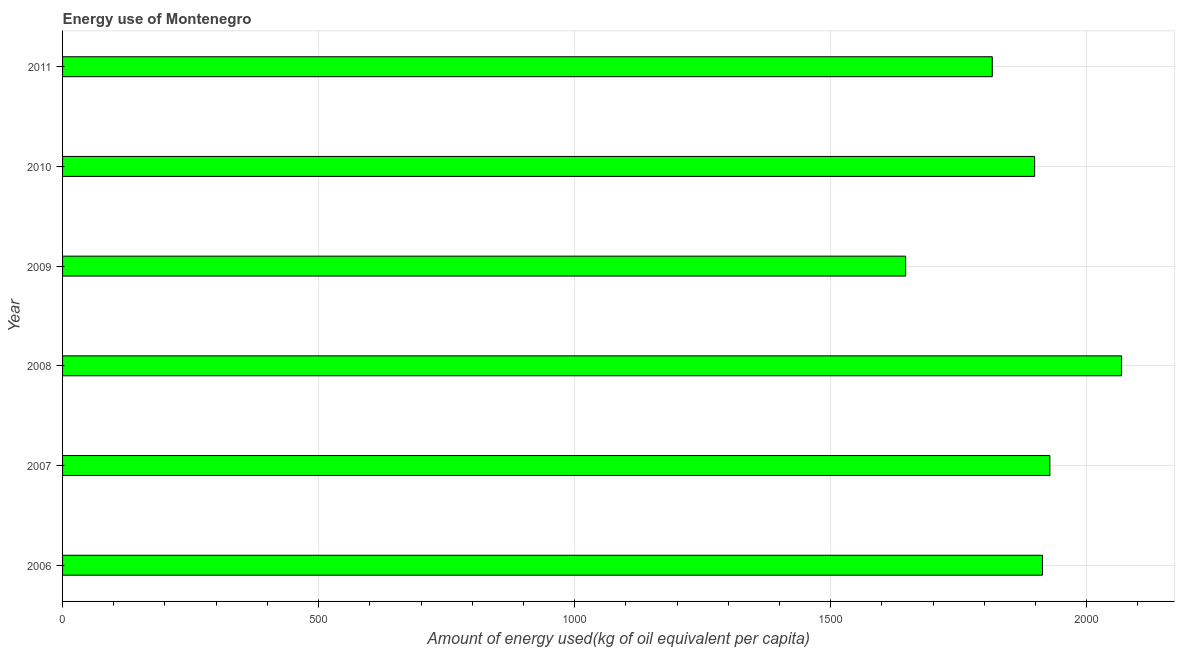Does the graph contain grids?
Provide a short and direct response. Yes. What is the title of the graph?
Offer a very short reply. Energy use of Montenegro. What is the label or title of the X-axis?
Ensure brevity in your answer.  Amount of energy used(kg of oil equivalent per capita). What is the amount of energy used in 2008?
Your answer should be very brief. 2067.97. Across all years, what is the maximum amount of energy used?
Make the answer very short. 2067.97. Across all years, what is the minimum amount of energy used?
Make the answer very short. 1646.31. In which year was the amount of energy used maximum?
Offer a very short reply. 2008. In which year was the amount of energy used minimum?
Provide a short and direct response. 2009. What is the sum of the amount of energy used?
Provide a short and direct response. 1.13e+04. What is the difference between the amount of energy used in 2008 and 2011?
Your answer should be very brief. 252.44. What is the average amount of energy used per year?
Offer a very short reply. 1878.27. What is the median amount of energy used?
Your answer should be compact. 1905.92. Do a majority of the years between 2011 and 2006 (inclusive) have amount of energy used greater than 1900 kg?
Provide a short and direct response. Yes. What is the ratio of the amount of energy used in 2006 to that in 2008?
Offer a very short reply. 0.93. Is the amount of energy used in 2006 less than that in 2007?
Your response must be concise. Yes. What is the difference between the highest and the second highest amount of energy used?
Your answer should be very brief. 139.99. Is the sum of the amount of energy used in 2006 and 2009 greater than the maximum amount of energy used across all years?
Make the answer very short. Yes. What is the difference between the highest and the lowest amount of energy used?
Your answer should be very brief. 421.66. In how many years, is the amount of energy used greater than the average amount of energy used taken over all years?
Your response must be concise. 4. How many years are there in the graph?
Your response must be concise. 6. What is the difference between two consecutive major ticks on the X-axis?
Make the answer very short. 500. What is the Amount of energy used(kg of oil equivalent per capita) of 2006?
Provide a short and direct response. 1913.56. What is the Amount of energy used(kg of oil equivalent per capita) in 2007?
Offer a terse response. 1927.98. What is the Amount of energy used(kg of oil equivalent per capita) of 2008?
Your response must be concise. 2067.97. What is the Amount of energy used(kg of oil equivalent per capita) of 2009?
Provide a short and direct response. 1646.31. What is the Amount of energy used(kg of oil equivalent per capita) of 2010?
Make the answer very short. 1898.29. What is the Amount of energy used(kg of oil equivalent per capita) of 2011?
Offer a terse response. 1815.53. What is the difference between the Amount of energy used(kg of oil equivalent per capita) in 2006 and 2007?
Offer a very short reply. -14.42. What is the difference between the Amount of energy used(kg of oil equivalent per capita) in 2006 and 2008?
Offer a very short reply. -154.41. What is the difference between the Amount of energy used(kg of oil equivalent per capita) in 2006 and 2009?
Your answer should be very brief. 267.24. What is the difference between the Amount of energy used(kg of oil equivalent per capita) in 2006 and 2010?
Give a very brief answer. 15.27. What is the difference between the Amount of energy used(kg of oil equivalent per capita) in 2006 and 2011?
Provide a succinct answer. 98.03. What is the difference between the Amount of energy used(kg of oil equivalent per capita) in 2007 and 2008?
Keep it short and to the point. -139.99. What is the difference between the Amount of energy used(kg of oil equivalent per capita) in 2007 and 2009?
Keep it short and to the point. 281.67. What is the difference between the Amount of energy used(kg of oil equivalent per capita) in 2007 and 2010?
Give a very brief answer. 29.69. What is the difference between the Amount of energy used(kg of oil equivalent per capita) in 2007 and 2011?
Keep it short and to the point. 112.45. What is the difference between the Amount of energy used(kg of oil equivalent per capita) in 2008 and 2009?
Ensure brevity in your answer.  421.66. What is the difference between the Amount of energy used(kg of oil equivalent per capita) in 2008 and 2010?
Your answer should be compact. 169.68. What is the difference between the Amount of energy used(kg of oil equivalent per capita) in 2008 and 2011?
Offer a terse response. 252.44. What is the difference between the Amount of energy used(kg of oil equivalent per capita) in 2009 and 2010?
Your answer should be very brief. -251.98. What is the difference between the Amount of energy used(kg of oil equivalent per capita) in 2009 and 2011?
Provide a short and direct response. -169.22. What is the difference between the Amount of energy used(kg of oil equivalent per capita) in 2010 and 2011?
Keep it short and to the point. 82.76. What is the ratio of the Amount of energy used(kg of oil equivalent per capita) in 2006 to that in 2007?
Give a very brief answer. 0.99. What is the ratio of the Amount of energy used(kg of oil equivalent per capita) in 2006 to that in 2008?
Offer a very short reply. 0.93. What is the ratio of the Amount of energy used(kg of oil equivalent per capita) in 2006 to that in 2009?
Your response must be concise. 1.16. What is the ratio of the Amount of energy used(kg of oil equivalent per capita) in 2006 to that in 2010?
Offer a very short reply. 1.01. What is the ratio of the Amount of energy used(kg of oil equivalent per capita) in 2006 to that in 2011?
Your answer should be very brief. 1.05. What is the ratio of the Amount of energy used(kg of oil equivalent per capita) in 2007 to that in 2008?
Your answer should be compact. 0.93. What is the ratio of the Amount of energy used(kg of oil equivalent per capita) in 2007 to that in 2009?
Offer a very short reply. 1.17. What is the ratio of the Amount of energy used(kg of oil equivalent per capita) in 2007 to that in 2010?
Ensure brevity in your answer.  1.02. What is the ratio of the Amount of energy used(kg of oil equivalent per capita) in 2007 to that in 2011?
Offer a terse response. 1.06. What is the ratio of the Amount of energy used(kg of oil equivalent per capita) in 2008 to that in 2009?
Offer a terse response. 1.26. What is the ratio of the Amount of energy used(kg of oil equivalent per capita) in 2008 to that in 2010?
Your response must be concise. 1.09. What is the ratio of the Amount of energy used(kg of oil equivalent per capita) in 2008 to that in 2011?
Provide a succinct answer. 1.14. What is the ratio of the Amount of energy used(kg of oil equivalent per capita) in 2009 to that in 2010?
Keep it short and to the point. 0.87. What is the ratio of the Amount of energy used(kg of oil equivalent per capita) in 2009 to that in 2011?
Your response must be concise. 0.91. What is the ratio of the Amount of energy used(kg of oil equivalent per capita) in 2010 to that in 2011?
Ensure brevity in your answer.  1.05. 